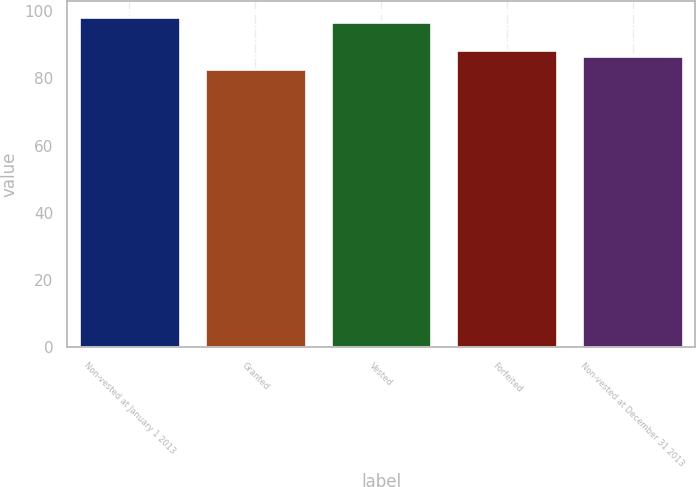Convert chart to OTSL. <chart><loc_0><loc_0><loc_500><loc_500><bar_chart><fcel>Non-vested at January 1 2013<fcel>Granted<fcel>Vested<fcel>Forfeited<fcel>Non-vested at December 31 2013<nl><fcel>98.23<fcel>82.95<fcel>96.79<fcel>88.61<fcel>86.7<nl></chart> 